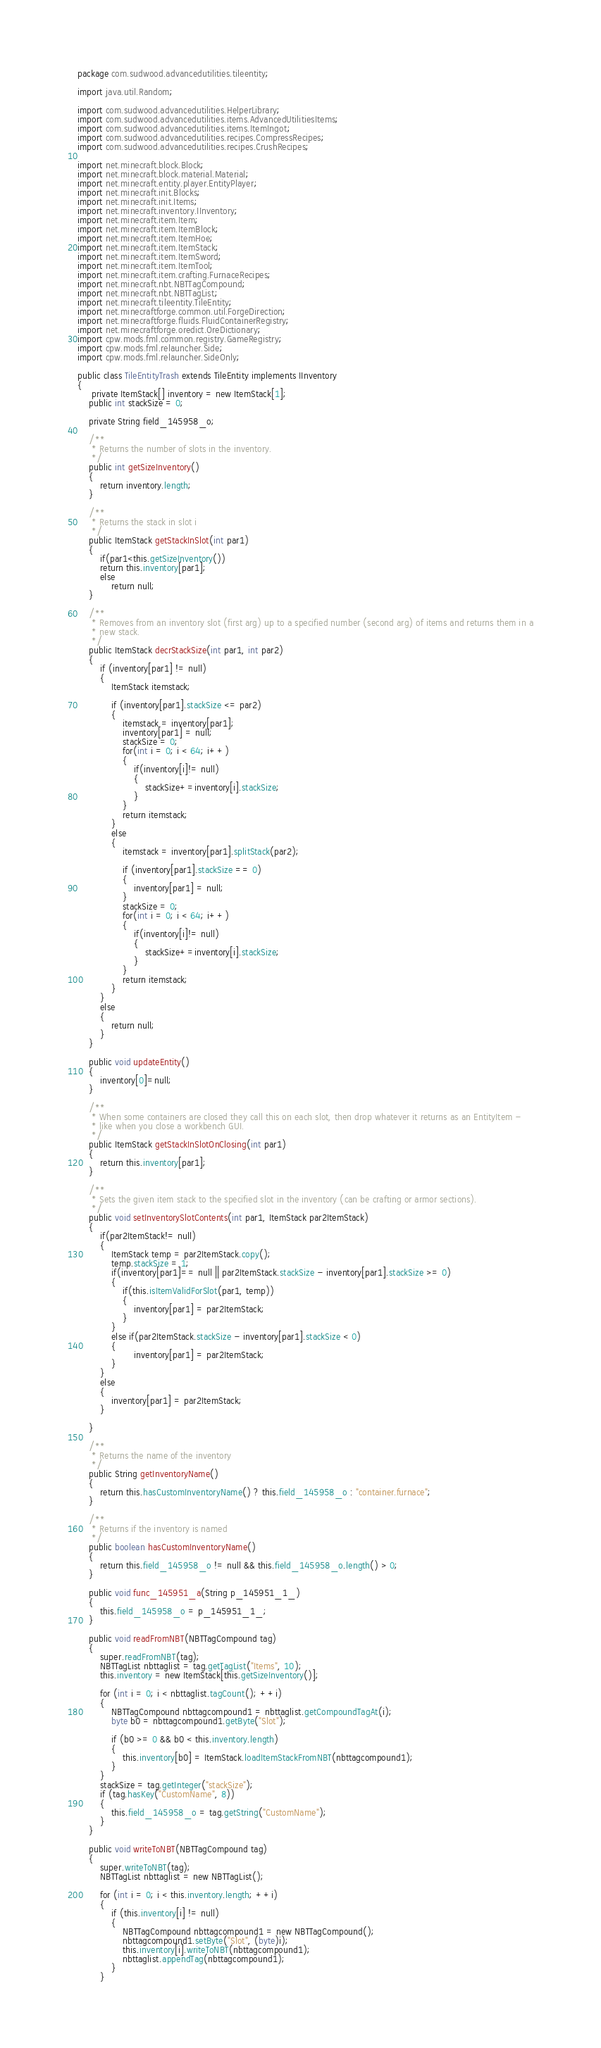<code> <loc_0><loc_0><loc_500><loc_500><_Java_>package com.sudwood.advancedutilities.tileentity;

import java.util.Random;

import com.sudwood.advancedutilities.HelperLibrary;
import com.sudwood.advancedutilities.items.AdvancedUtilitiesItems;
import com.sudwood.advancedutilities.items.ItemIngot;
import com.sudwood.advancedutilities.recipes.CompressRecipes;
import com.sudwood.advancedutilities.recipes.CrushRecipes;

import net.minecraft.block.Block;
import net.minecraft.block.material.Material;
import net.minecraft.entity.player.EntityPlayer;
import net.minecraft.init.Blocks;
import net.minecraft.init.Items;
import net.minecraft.inventory.IInventory;
import net.minecraft.item.Item;
import net.minecraft.item.ItemBlock;
import net.minecraft.item.ItemHoe;
import net.minecraft.item.ItemStack;
import net.minecraft.item.ItemSword;
import net.minecraft.item.ItemTool;
import net.minecraft.item.crafting.FurnaceRecipes;
import net.minecraft.nbt.NBTTagCompound;
import net.minecraft.nbt.NBTTagList;
import net.minecraft.tileentity.TileEntity;
import net.minecraftforge.common.util.ForgeDirection;
import net.minecraftforge.fluids.FluidContainerRegistry;
import net.minecraftforge.oredict.OreDictionary;
import cpw.mods.fml.common.registry.GameRegistry;
import cpw.mods.fml.relauncher.Side;
import cpw.mods.fml.relauncher.SideOnly;

public class TileEntityTrash extends TileEntity implements IInventory
{
	 private ItemStack[] inventory = new ItemStack[1];
    public int stackSize = 0;

    private String field_145958_o;

    /**
     * Returns the number of slots in the inventory.
     */
    public int getSizeInventory()
    {
        return inventory.length;
    }

    /**
     * Returns the stack in slot i
     */
    public ItemStack getStackInSlot(int par1)
    {
    	if(par1<this.getSizeInventory())
        return this.inventory[par1];
    	else
    		return null;
    }

    /**
     * Removes from an inventory slot (first arg) up to a specified number (second arg) of items and returns them in a
     * new stack.
     */
    public ItemStack decrStackSize(int par1, int par2)
    {
        if (inventory[par1] != null)
        {
            ItemStack itemstack;

            if (inventory[par1].stackSize <= par2)
            {
                itemstack = inventory[par1];
                inventory[par1] = null;
                stackSize = 0;
                for(int i = 0; i < 64; i++)
                {
                	if(inventory[i]!= null)
                	{
                		stackSize+=inventory[i].stackSize;
                	}
                }
                return itemstack;
            }
            else
            {
                itemstack = inventory[par1].splitStack(par2);

                if (inventory[par1].stackSize == 0)
                {
                    inventory[par1] = null;
                }
                stackSize = 0;
                for(int i = 0; i < 64; i++)
                {
                	if(inventory[i]!= null)
                	{
                		stackSize+=inventory[i].stackSize;
                	}
                }
                return itemstack;
            }
        }
        else
        {
            return null;
        }
    }
    
    public void updateEntity()
    {
    	inventory[0]=null;
    }

    /**
     * When some containers are closed they call this on each slot, then drop whatever it returns as an EntityItem -
     * like when you close a workbench GUI.
     */
    public ItemStack getStackInSlotOnClosing(int par1)
    {
        return this.inventory[par1];
    }

    /**
     * Sets the given item stack to the specified slot in the inventory (can be crafting or armor sections).
     */
    public void setInventorySlotContents(int par1, ItemStack par2ItemStack)
    {
    	if(par2ItemStack!= null)
    	{
    		ItemStack temp = par2ItemStack.copy();
    		temp.stackSize = 1;
    		if(inventory[par1]== null || par2ItemStack.stackSize - inventory[par1].stackSize >= 0)
    		{
	    		if(this.isItemValidForSlot(par1, temp))
	    		{
	    			inventory[par1] = par2ItemStack;
	    		}
    		}
    		else if(par2ItemStack.stackSize - inventory[par1].stackSize < 0)
    		{
    				inventory[par1] = par2ItemStack;
    		}
    	}
    	else
    	{
    		inventory[par1] = par2ItemStack;
    	}
        
    }

    /**
     * Returns the name of the inventory
     */
    public String getInventoryName()
    {
        return this.hasCustomInventoryName() ? this.field_145958_o : "container.furnace";
    }

    /**
     * Returns if the inventory is named
     */
    public boolean hasCustomInventoryName()
    {
        return this.field_145958_o != null && this.field_145958_o.length() > 0;
    }

    public void func_145951_a(String p_145951_1_)
    {
        this.field_145958_o = p_145951_1_;
    }

    public void readFromNBT(NBTTagCompound tag)
    {
        super.readFromNBT(tag);
        NBTTagList nbttaglist = tag.getTagList("Items", 10);
        this.inventory = new ItemStack[this.getSizeInventory()];

        for (int i = 0; i < nbttaglist.tagCount(); ++i)
        {
            NBTTagCompound nbttagcompound1 = nbttaglist.getCompoundTagAt(i);
            byte b0 = nbttagcompound1.getByte("Slot");

            if (b0 >= 0 && b0 < this.inventory.length)
            {
                this.inventory[b0] = ItemStack.loadItemStackFromNBT(nbttagcompound1);
            }
        }
        stackSize = tag.getInteger("stackSize");
        if (tag.hasKey("CustomName", 8))
        {
            this.field_145958_o = tag.getString("CustomName");
        }
    }

    public void writeToNBT(NBTTagCompound tag)
    {
        super.writeToNBT(tag);
        NBTTagList nbttaglist = new NBTTagList();

        for (int i = 0; i < this.inventory.length; ++i)
        {
            if (this.inventory[i] != null)
            {
                NBTTagCompound nbttagcompound1 = new NBTTagCompound();
                nbttagcompound1.setByte("Slot", (byte)i);
                this.inventory[i].writeToNBT(nbttagcompound1);
                nbttaglist.appendTag(nbttagcompound1);
            }
        }
</code> 